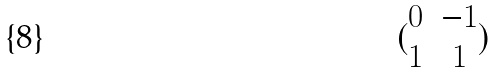Convert formula to latex. <formula><loc_0><loc_0><loc_500><loc_500>( \begin{matrix} 0 & - 1 \\ 1 & 1 \end{matrix} )</formula> 